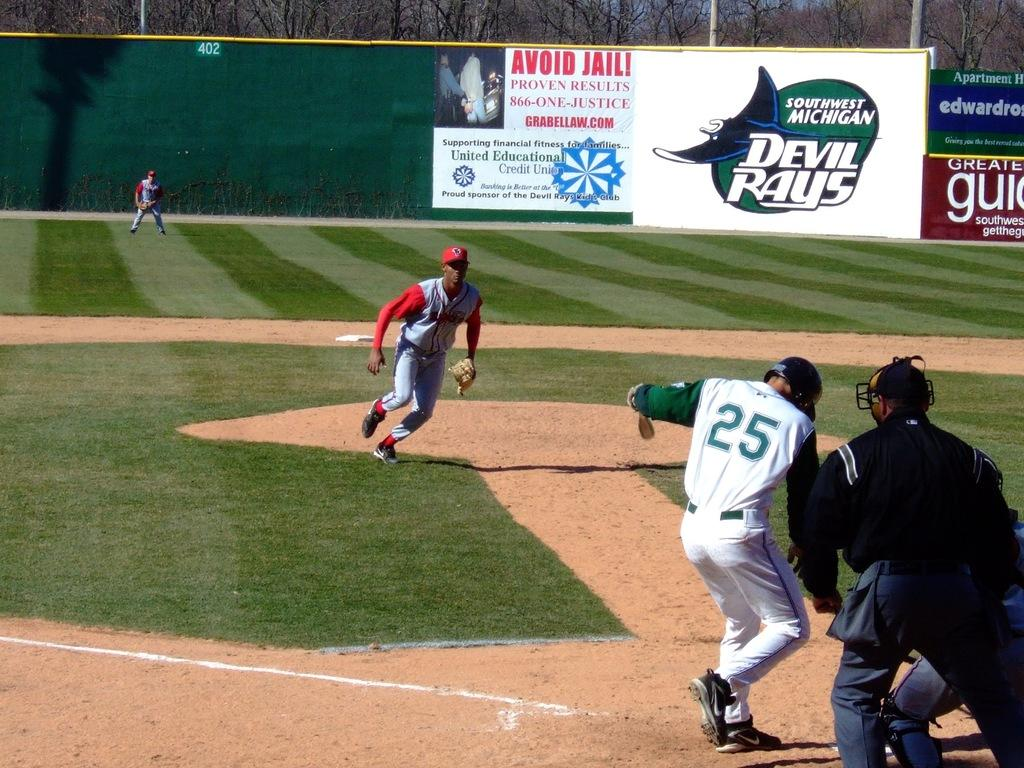<image>
Provide a brief description of the given image. Baseball players playing a game with the batter being number 25 and the game sponsored by Devil rays. 